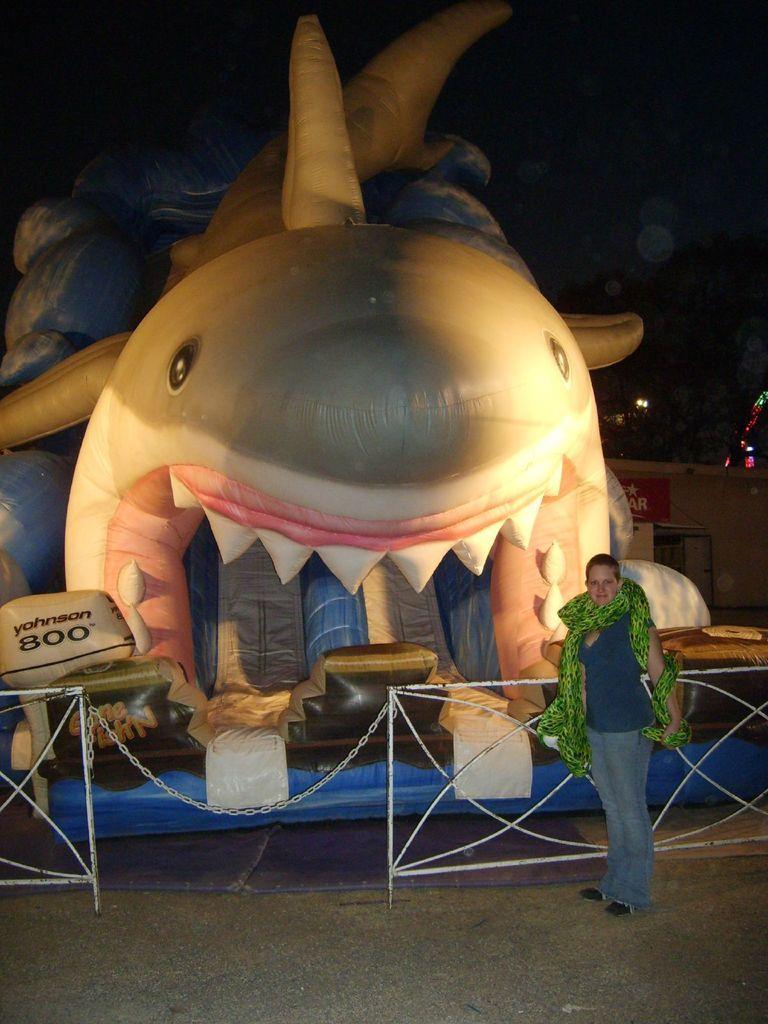In one or two sentences, can you explain what this image depicts? In this picture we can see a person standing on the ground, at back of this person we can see a fence, inflatable object, building, lights and some objects and in the background we can see it is dark. 